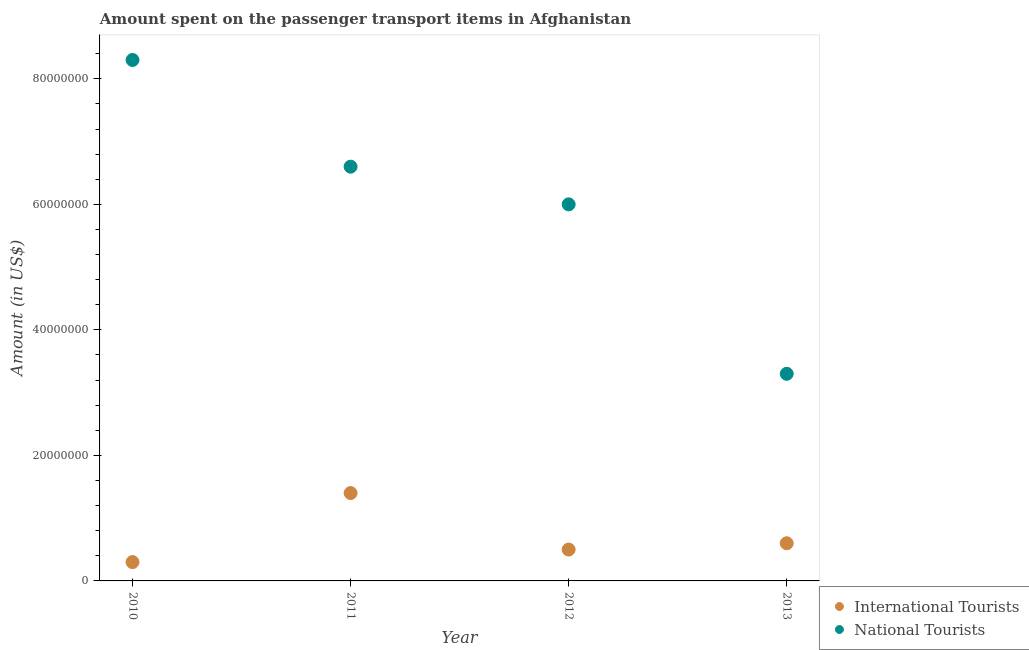How many different coloured dotlines are there?
Make the answer very short. 2. What is the amount spent on transport items of international tourists in 2011?
Offer a very short reply. 1.40e+07. Across all years, what is the maximum amount spent on transport items of international tourists?
Your answer should be compact. 1.40e+07. Across all years, what is the minimum amount spent on transport items of national tourists?
Your response must be concise. 3.30e+07. In which year was the amount spent on transport items of national tourists minimum?
Offer a terse response. 2013. What is the total amount spent on transport items of international tourists in the graph?
Provide a succinct answer. 2.80e+07. What is the difference between the amount spent on transport items of international tourists in 2012 and that in 2013?
Give a very brief answer. -1.00e+06. What is the difference between the amount spent on transport items of international tourists in 2011 and the amount spent on transport items of national tourists in 2010?
Make the answer very short. -6.90e+07. What is the average amount spent on transport items of international tourists per year?
Your response must be concise. 7.00e+06. In the year 2010, what is the difference between the amount spent on transport items of national tourists and amount spent on transport items of international tourists?
Your answer should be compact. 8.00e+07. In how many years, is the amount spent on transport items of international tourists greater than 52000000 US$?
Provide a short and direct response. 0. What is the ratio of the amount spent on transport items of international tourists in 2011 to that in 2012?
Your answer should be compact. 2.8. What is the difference between the highest and the lowest amount spent on transport items of national tourists?
Offer a terse response. 5.00e+07. In how many years, is the amount spent on transport items of national tourists greater than the average amount spent on transport items of national tourists taken over all years?
Your answer should be very brief. 2. Is the sum of the amount spent on transport items of national tourists in 2011 and 2012 greater than the maximum amount spent on transport items of international tourists across all years?
Provide a succinct answer. Yes. Are the values on the major ticks of Y-axis written in scientific E-notation?
Provide a short and direct response. No. How are the legend labels stacked?
Your answer should be compact. Vertical. What is the title of the graph?
Ensure brevity in your answer.  Amount spent on the passenger transport items in Afghanistan. Does "Fertility rate" appear as one of the legend labels in the graph?
Ensure brevity in your answer.  No. What is the label or title of the X-axis?
Your answer should be compact. Year. What is the label or title of the Y-axis?
Provide a short and direct response. Amount (in US$). What is the Amount (in US$) in National Tourists in 2010?
Provide a short and direct response. 8.30e+07. What is the Amount (in US$) in International Tourists in 2011?
Provide a succinct answer. 1.40e+07. What is the Amount (in US$) of National Tourists in 2011?
Offer a terse response. 6.60e+07. What is the Amount (in US$) in National Tourists in 2012?
Your answer should be very brief. 6.00e+07. What is the Amount (in US$) in International Tourists in 2013?
Offer a terse response. 6.00e+06. What is the Amount (in US$) of National Tourists in 2013?
Your answer should be very brief. 3.30e+07. Across all years, what is the maximum Amount (in US$) in International Tourists?
Your answer should be very brief. 1.40e+07. Across all years, what is the maximum Amount (in US$) of National Tourists?
Give a very brief answer. 8.30e+07. Across all years, what is the minimum Amount (in US$) in International Tourists?
Provide a short and direct response. 3.00e+06. Across all years, what is the minimum Amount (in US$) in National Tourists?
Ensure brevity in your answer.  3.30e+07. What is the total Amount (in US$) in International Tourists in the graph?
Ensure brevity in your answer.  2.80e+07. What is the total Amount (in US$) in National Tourists in the graph?
Your answer should be compact. 2.42e+08. What is the difference between the Amount (in US$) of International Tourists in 2010 and that in 2011?
Ensure brevity in your answer.  -1.10e+07. What is the difference between the Amount (in US$) in National Tourists in 2010 and that in 2011?
Offer a very short reply. 1.70e+07. What is the difference between the Amount (in US$) in International Tourists in 2010 and that in 2012?
Provide a succinct answer. -2.00e+06. What is the difference between the Amount (in US$) of National Tourists in 2010 and that in 2012?
Provide a short and direct response. 2.30e+07. What is the difference between the Amount (in US$) of International Tourists in 2011 and that in 2012?
Provide a succinct answer. 9.00e+06. What is the difference between the Amount (in US$) in National Tourists in 2011 and that in 2012?
Offer a very short reply. 6.00e+06. What is the difference between the Amount (in US$) of International Tourists in 2011 and that in 2013?
Give a very brief answer. 8.00e+06. What is the difference between the Amount (in US$) of National Tourists in 2011 and that in 2013?
Offer a terse response. 3.30e+07. What is the difference between the Amount (in US$) in International Tourists in 2012 and that in 2013?
Ensure brevity in your answer.  -1.00e+06. What is the difference between the Amount (in US$) in National Tourists in 2012 and that in 2013?
Your response must be concise. 2.70e+07. What is the difference between the Amount (in US$) of International Tourists in 2010 and the Amount (in US$) of National Tourists in 2011?
Make the answer very short. -6.30e+07. What is the difference between the Amount (in US$) of International Tourists in 2010 and the Amount (in US$) of National Tourists in 2012?
Your response must be concise. -5.70e+07. What is the difference between the Amount (in US$) of International Tourists in 2010 and the Amount (in US$) of National Tourists in 2013?
Your answer should be very brief. -3.00e+07. What is the difference between the Amount (in US$) in International Tourists in 2011 and the Amount (in US$) in National Tourists in 2012?
Offer a very short reply. -4.60e+07. What is the difference between the Amount (in US$) of International Tourists in 2011 and the Amount (in US$) of National Tourists in 2013?
Keep it short and to the point. -1.90e+07. What is the difference between the Amount (in US$) of International Tourists in 2012 and the Amount (in US$) of National Tourists in 2013?
Ensure brevity in your answer.  -2.80e+07. What is the average Amount (in US$) of National Tourists per year?
Your response must be concise. 6.05e+07. In the year 2010, what is the difference between the Amount (in US$) of International Tourists and Amount (in US$) of National Tourists?
Your answer should be compact. -8.00e+07. In the year 2011, what is the difference between the Amount (in US$) of International Tourists and Amount (in US$) of National Tourists?
Offer a terse response. -5.20e+07. In the year 2012, what is the difference between the Amount (in US$) of International Tourists and Amount (in US$) of National Tourists?
Offer a very short reply. -5.50e+07. In the year 2013, what is the difference between the Amount (in US$) in International Tourists and Amount (in US$) in National Tourists?
Provide a succinct answer. -2.70e+07. What is the ratio of the Amount (in US$) of International Tourists in 2010 to that in 2011?
Your response must be concise. 0.21. What is the ratio of the Amount (in US$) in National Tourists in 2010 to that in 2011?
Offer a terse response. 1.26. What is the ratio of the Amount (in US$) in National Tourists in 2010 to that in 2012?
Provide a short and direct response. 1.38. What is the ratio of the Amount (in US$) of International Tourists in 2010 to that in 2013?
Provide a succinct answer. 0.5. What is the ratio of the Amount (in US$) of National Tourists in 2010 to that in 2013?
Your answer should be compact. 2.52. What is the ratio of the Amount (in US$) of International Tourists in 2011 to that in 2013?
Provide a short and direct response. 2.33. What is the ratio of the Amount (in US$) of National Tourists in 2012 to that in 2013?
Your answer should be compact. 1.82. What is the difference between the highest and the second highest Amount (in US$) of International Tourists?
Your response must be concise. 8.00e+06. What is the difference between the highest and the second highest Amount (in US$) of National Tourists?
Your response must be concise. 1.70e+07. What is the difference between the highest and the lowest Amount (in US$) in International Tourists?
Your response must be concise. 1.10e+07. What is the difference between the highest and the lowest Amount (in US$) of National Tourists?
Offer a terse response. 5.00e+07. 